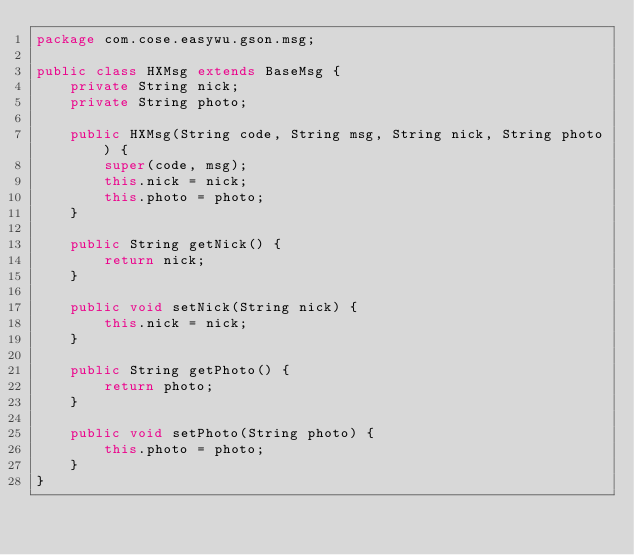Convert code to text. <code><loc_0><loc_0><loc_500><loc_500><_Java_>package com.cose.easywu.gson.msg;

public class HXMsg extends BaseMsg {
    private String nick;
    private String photo;

    public HXMsg(String code, String msg, String nick, String photo) {
        super(code, msg);
        this.nick = nick;
        this.photo = photo;
    }

    public String getNick() {
        return nick;
    }

    public void setNick(String nick) {
        this.nick = nick;
    }

    public String getPhoto() {
        return photo;
    }

    public void setPhoto(String photo) {
        this.photo = photo;
    }
}
</code> 